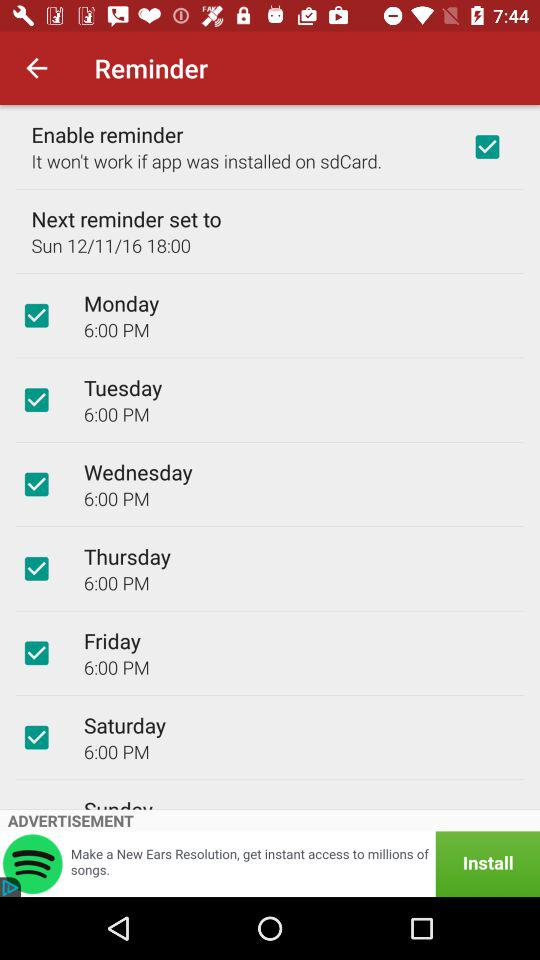The next reminder is set for what date? The date is Sunday, December 11, 16. 